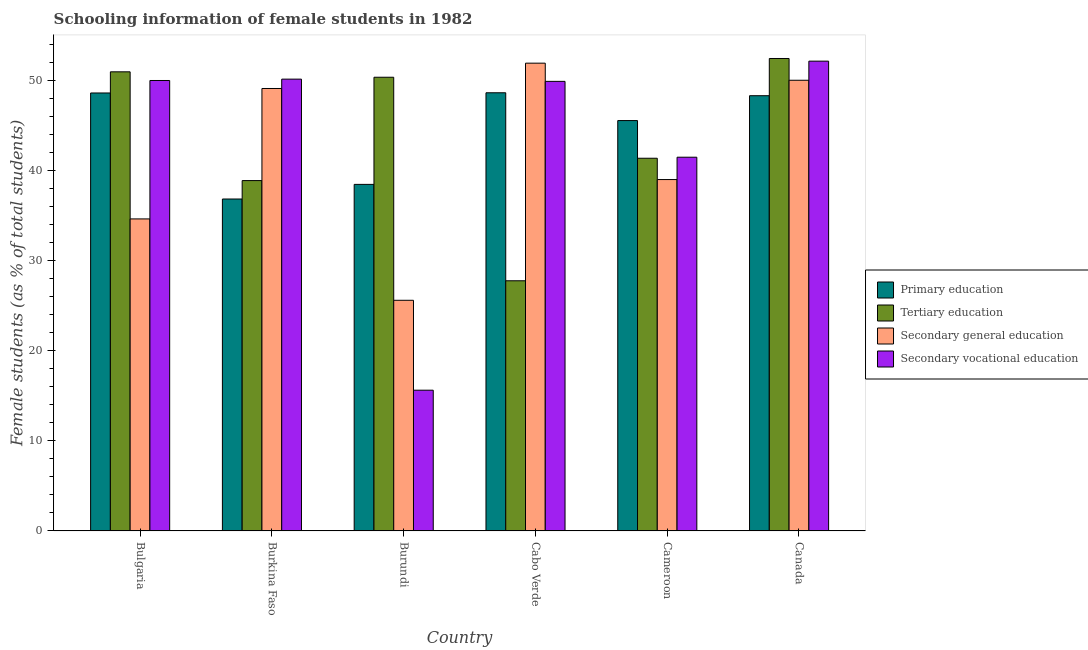How many different coloured bars are there?
Offer a terse response. 4. How many groups of bars are there?
Your answer should be very brief. 6. Are the number of bars per tick equal to the number of legend labels?
Provide a succinct answer. Yes. Are the number of bars on each tick of the X-axis equal?
Make the answer very short. Yes. What is the label of the 2nd group of bars from the left?
Your answer should be very brief. Burkina Faso. What is the percentage of female students in tertiary education in Cameroon?
Provide a short and direct response. 41.37. Across all countries, what is the maximum percentage of female students in secondary vocational education?
Your answer should be very brief. 52.15. Across all countries, what is the minimum percentage of female students in primary education?
Your answer should be very brief. 36.84. In which country was the percentage of female students in primary education maximum?
Keep it short and to the point. Cabo Verde. In which country was the percentage of female students in tertiary education minimum?
Offer a terse response. Cabo Verde. What is the total percentage of female students in secondary vocational education in the graph?
Your response must be concise. 259.31. What is the difference between the percentage of female students in secondary education in Bulgaria and that in Burkina Faso?
Ensure brevity in your answer.  -14.48. What is the difference between the percentage of female students in tertiary education in Burkina Faso and the percentage of female students in secondary education in Burundi?
Provide a succinct answer. 13.29. What is the average percentage of female students in primary education per country?
Provide a short and direct response. 44.4. What is the difference between the percentage of female students in tertiary education and percentage of female students in secondary vocational education in Bulgaria?
Keep it short and to the point. 0.96. What is the ratio of the percentage of female students in primary education in Burkina Faso to that in Canada?
Your answer should be very brief. 0.76. Is the percentage of female students in primary education in Bulgaria less than that in Canada?
Your answer should be very brief. No. What is the difference between the highest and the second highest percentage of female students in secondary vocational education?
Make the answer very short. 2. What is the difference between the highest and the lowest percentage of female students in tertiary education?
Your response must be concise. 24.67. In how many countries, is the percentage of female students in tertiary education greater than the average percentage of female students in tertiary education taken over all countries?
Provide a succinct answer. 3. Is the sum of the percentage of female students in primary education in Burkina Faso and Canada greater than the maximum percentage of female students in secondary vocational education across all countries?
Ensure brevity in your answer.  Yes. What does the 4th bar from the left in Burundi represents?
Make the answer very short. Secondary vocational education. What does the 3rd bar from the right in Canada represents?
Your answer should be compact. Tertiary education. Are all the bars in the graph horizontal?
Your answer should be very brief. No. How many countries are there in the graph?
Your response must be concise. 6. Does the graph contain any zero values?
Your answer should be compact. No. Does the graph contain grids?
Give a very brief answer. No. Where does the legend appear in the graph?
Make the answer very short. Center right. How many legend labels are there?
Provide a short and direct response. 4. What is the title of the graph?
Your response must be concise. Schooling information of female students in 1982. Does "Arable land" appear as one of the legend labels in the graph?
Give a very brief answer. No. What is the label or title of the Y-axis?
Provide a succinct answer. Female students (as % of total students). What is the Female students (as % of total students) of Primary education in Bulgaria?
Keep it short and to the point. 48.61. What is the Female students (as % of total students) in Tertiary education in Bulgaria?
Offer a terse response. 50.96. What is the Female students (as % of total students) in Secondary general education in Bulgaria?
Give a very brief answer. 34.63. What is the Female students (as % of total students) in Secondary vocational education in Bulgaria?
Make the answer very short. 50. What is the Female students (as % of total students) in Primary education in Burkina Faso?
Provide a short and direct response. 36.84. What is the Female students (as % of total students) in Tertiary education in Burkina Faso?
Give a very brief answer. 38.89. What is the Female students (as % of total students) in Secondary general education in Burkina Faso?
Keep it short and to the point. 49.11. What is the Female students (as % of total students) of Secondary vocational education in Burkina Faso?
Your answer should be very brief. 50.15. What is the Female students (as % of total students) in Primary education in Burundi?
Make the answer very short. 38.47. What is the Female students (as % of total students) in Tertiary education in Burundi?
Keep it short and to the point. 50.36. What is the Female students (as % of total students) of Secondary general education in Burundi?
Offer a very short reply. 25.6. What is the Female students (as % of total students) of Secondary vocational education in Burundi?
Your response must be concise. 15.62. What is the Female students (as % of total students) of Primary education in Cabo Verde?
Make the answer very short. 48.64. What is the Female students (as % of total students) in Tertiary education in Cabo Verde?
Keep it short and to the point. 27.77. What is the Female students (as % of total students) in Secondary general education in Cabo Verde?
Offer a terse response. 51.92. What is the Female students (as % of total students) in Secondary vocational education in Cabo Verde?
Offer a terse response. 49.9. What is the Female students (as % of total students) in Primary education in Cameroon?
Ensure brevity in your answer.  45.55. What is the Female students (as % of total students) of Tertiary education in Cameroon?
Provide a succinct answer. 41.37. What is the Female students (as % of total students) in Secondary general education in Cameroon?
Provide a short and direct response. 39. What is the Female students (as % of total students) in Secondary vocational education in Cameroon?
Offer a very short reply. 41.48. What is the Female students (as % of total students) in Primary education in Canada?
Provide a succinct answer. 48.31. What is the Female students (as % of total students) of Tertiary education in Canada?
Provide a short and direct response. 52.44. What is the Female students (as % of total students) in Secondary general education in Canada?
Provide a short and direct response. 50.03. What is the Female students (as % of total students) of Secondary vocational education in Canada?
Your response must be concise. 52.15. Across all countries, what is the maximum Female students (as % of total students) in Primary education?
Ensure brevity in your answer.  48.64. Across all countries, what is the maximum Female students (as % of total students) of Tertiary education?
Provide a short and direct response. 52.44. Across all countries, what is the maximum Female students (as % of total students) of Secondary general education?
Offer a terse response. 51.92. Across all countries, what is the maximum Female students (as % of total students) in Secondary vocational education?
Make the answer very short. 52.15. Across all countries, what is the minimum Female students (as % of total students) in Primary education?
Ensure brevity in your answer.  36.84. Across all countries, what is the minimum Female students (as % of total students) in Tertiary education?
Provide a short and direct response. 27.77. Across all countries, what is the minimum Female students (as % of total students) of Secondary general education?
Keep it short and to the point. 25.6. Across all countries, what is the minimum Female students (as % of total students) of Secondary vocational education?
Give a very brief answer. 15.62. What is the total Female students (as % of total students) of Primary education in the graph?
Offer a very short reply. 266.42. What is the total Female students (as % of total students) in Tertiary education in the graph?
Your response must be concise. 261.79. What is the total Female students (as % of total students) in Secondary general education in the graph?
Offer a very short reply. 250.3. What is the total Female students (as % of total students) in Secondary vocational education in the graph?
Keep it short and to the point. 259.31. What is the difference between the Female students (as % of total students) of Primary education in Bulgaria and that in Burkina Faso?
Ensure brevity in your answer.  11.77. What is the difference between the Female students (as % of total students) of Tertiary education in Bulgaria and that in Burkina Faso?
Offer a very short reply. 12.07. What is the difference between the Female students (as % of total students) in Secondary general education in Bulgaria and that in Burkina Faso?
Give a very brief answer. -14.48. What is the difference between the Female students (as % of total students) in Secondary vocational education in Bulgaria and that in Burkina Faso?
Give a very brief answer. -0.15. What is the difference between the Female students (as % of total students) in Primary education in Bulgaria and that in Burundi?
Keep it short and to the point. 10.15. What is the difference between the Female students (as % of total students) of Tertiary education in Bulgaria and that in Burundi?
Ensure brevity in your answer.  0.6. What is the difference between the Female students (as % of total students) in Secondary general education in Bulgaria and that in Burundi?
Offer a terse response. 9.03. What is the difference between the Female students (as % of total students) of Secondary vocational education in Bulgaria and that in Burundi?
Give a very brief answer. 34.38. What is the difference between the Female students (as % of total students) in Primary education in Bulgaria and that in Cabo Verde?
Keep it short and to the point. -0.02. What is the difference between the Female students (as % of total students) in Tertiary education in Bulgaria and that in Cabo Verde?
Provide a short and direct response. 23.19. What is the difference between the Female students (as % of total students) in Secondary general education in Bulgaria and that in Cabo Verde?
Your answer should be very brief. -17.29. What is the difference between the Female students (as % of total students) of Secondary vocational education in Bulgaria and that in Cabo Verde?
Your answer should be compact. 0.1. What is the difference between the Female students (as % of total students) in Primary education in Bulgaria and that in Cameroon?
Offer a very short reply. 3.06. What is the difference between the Female students (as % of total students) in Tertiary education in Bulgaria and that in Cameroon?
Keep it short and to the point. 9.59. What is the difference between the Female students (as % of total students) of Secondary general education in Bulgaria and that in Cameroon?
Make the answer very short. -4.37. What is the difference between the Female students (as % of total students) of Secondary vocational education in Bulgaria and that in Cameroon?
Provide a short and direct response. 8.52. What is the difference between the Female students (as % of total students) in Primary education in Bulgaria and that in Canada?
Keep it short and to the point. 0.3. What is the difference between the Female students (as % of total students) of Tertiary education in Bulgaria and that in Canada?
Make the answer very short. -1.48. What is the difference between the Female students (as % of total students) of Secondary general education in Bulgaria and that in Canada?
Offer a very short reply. -15.39. What is the difference between the Female students (as % of total students) in Secondary vocational education in Bulgaria and that in Canada?
Offer a terse response. -2.15. What is the difference between the Female students (as % of total students) in Primary education in Burkina Faso and that in Burundi?
Keep it short and to the point. -1.62. What is the difference between the Female students (as % of total students) of Tertiary education in Burkina Faso and that in Burundi?
Your answer should be very brief. -11.47. What is the difference between the Female students (as % of total students) of Secondary general education in Burkina Faso and that in Burundi?
Your answer should be compact. 23.51. What is the difference between the Female students (as % of total students) in Secondary vocational education in Burkina Faso and that in Burundi?
Provide a short and direct response. 34.53. What is the difference between the Female students (as % of total students) of Primary education in Burkina Faso and that in Cabo Verde?
Provide a short and direct response. -11.79. What is the difference between the Female students (as % of total students) of Tertiary education in Burkina Faso and that in Cabo Verde?
Keep it short and to the point. 11.12. What is the difference between the Female students (as % of total students) of Secondary general education in Burkina Faso and that in Cabo Verde?
Provide a short and direct response. -2.81. What is the difference between the Female students (as % of total students) in Secondary vocational education in Burkina Faso and that in Cabo Verde?
Your answer should be compact. 0.25. What is the difference between the Female students (as % of total students) of Primary education in Burkina Faso and that in Cameroon?
Provide a succinct answer. -8.71. What is the difference between the Female students (as % of total students) in Tertiary education in Burkina Faso and that in Cameroon?
Offer a very short reply. -2.48. What is the difference between the Female students (as % of total students) of Secondary general education in Burkina Faso and that in Cameroon?
Give a very brief answer. 10.11. What is the difference between the Female students (as % of total students) of Secondary vocational education in Burkina Faso and that in Cameroon?
Make the answer very short. 8.67. What is the difference between the Female students (as % of total students) in Primary education in Burkina Faso and that in Canada?
Offer a very short reply. -11.47. What is the difference between the Female students (as % of total students) of Tertiary education in Burkina Faso and that in Canada?
Make the answer very short. -13.55. What is the difference between the Female students (as % of total students) in Secondary general education in Burkina Faso and that in Canada?
Your response must be concise. -0.91. What is the difference between the Female students (as % of total students) in Secondary vocational education in Burkina Faso and that in Canada?
Your response must be concise. -2. What is the difference between the Female students (as % of total students) in Primary education in Burundi and that in Cabo Verde?
Offer a very short reply. -10.17. What is the difference between the Female students (as % of total students) in Tertiary education in Burundi and that in Cabo Verde?
Offer a very short reply. 22.59. What is the difference between the Female students (as % of total students) of Secondary general education in Burundi and that in Cabo Verde?
Your answer should be compact. -26.32. What is the difference between the Female students (as % of total students) of Secondary vocational education in Burundi and that in Cabo Verde?
Provide a short and direct response. -34.28. What is the difference between the Female students (as % of total students) of Primary education in Burundi and that in Cameroon?
Provide a succinct answer. -7.08. What is the difference between the Female students (as % of total students) in Tertiary education in Burundi and that in Cameroon?
Offer a terse response. 8.99. What is the difference between the Female students (as % of total students) in Secondary general education in Burundi and that in Cameroon?
Ensure brevity in your answer.  -13.4. What is the difference between the Female students (as % of total students) in Secondary vocational education in Burundi and that in Cameroon?
Offer a terse response. -25.86. What is the difference between the Female students (as % of total students) of Primary education in Burundi and that in Canada?
Offer a terse response. -9.84. What is the difference between the Female students (as % of total students) in Tertiary education in Burundi and that in Canada?
Your answer should be very brief. -2.08. What is the difference between the Female students (as % of total students) of Secondary general education in Burundi and that in Canada?
Your answer should be compact. -24.42. What is the difference between the Female students (as % of total students) of Secondary vocational education in Burundi and that in Canada?
Make the answer very short. -36.52. What is the difference between the Female students (as % of total students) in Primary education in Cabo Verde and that in Cameroon?
Offer a very short reply. 3.09. What is the difference between the Female students (as % of total students) of Tertiary education in Cabo Verde and that in Cameroon?
Provide a short and direct response. -13.6. What is the difference between the Female students (as % of total students) in Secondary general education in Cabo Verde and that in Cameroon?
Keep it short and to the point. 12.92. What is the difference between the Female students (as % of total students) in Secondary vocational education in Cabo Verde and that in Cameroon?
Provide a succinct answer. 8.42. What is the difference between the Female students (as % of total students) of Primary education in Cabo Verde and that in Canada?
Make the answer very short. 0.33. What is the difference between the Female students (as % of total students) of Tertiary education in Cabo Verde and that in Canada?
Make the answer very short. -24.67. What is the difference between the Female students (as % of total students) in Secondary general education in Cabo Verde and that in Canada?
Offer a terse response. 1.9. What is the difference between the Female students (as % of total students) in Secondary vocational education in Cabo Verde and that in Canada?
Provide a succinct answer. -2.24. What is the difference between the Female students (as % of total students) of Primary education in Cameroon and that in Canada?
Provide a succinct answer. -2.76. What is the difference between the Female students (as % of total students) of Tertiary education in Cameroon and that in Canada?
Your answer should be compact. -11.07. What is the difference between the Female students (as % of total students) of Secondary general education in Cameroon and that in Canada?
Your answer should be compact. -11.02. What is the difference between the Female students (as % of total students) in Secondary vocational education in Cameroon and that in Canada?
Offer a terse response. -10.66. What is the difference between the Female students (as % of total students) in Primary education in Bulgaria and the Female students (as % of total students) in Tertiary education in Burkina Faso?
Ensure brevity in your answer.  9.72. What is the difference between the Female students (as % of total students) in Primary education in Bulgaria and the Female students (as % of total students) in Secondary general education in Burkina Faso?
Make the answer very short. -0.5. What is the difference between the Female students (as % of total students) in Primary education in Bulgaria and the Female students (as % of total students) in Secondary vocational education in Burkina Faso?
Provide a short and direct response. -1.54. What is the difference between the Female students (as % of total students) of Tertiary education in Bulgaria and the Female students (as % of total students) of Secondary general education in Burkina Faso?
Your answer should be compact. 1.85. What is the difference between the Female students (as % of total students) in Tertiary education in Bulgaria and the Female students (as % of total students) in Secondary vocational education in Burkina Faso?
Give a very brief answer. 0.81. What is the difference between the Female students (as % of total students) of Secondary general education in Bulgaria and the Female students (as % of total students) of Secondary vocational education in Burkina Faso?
Keep it short and to the point. -15.52. What is the difference between the Female students (as % of total students) of Primary education in Bulgaria and the Female students (as % of total students) of Tertiary education in Burundi?
Your answer should be very brief. -1.75. What is the difference between the Female students (as % of total students) in Primary education in Bulgaria and the Female students (as % of total students) in Secondary general education in Burundi?
Keep it short and to the point. 23.01. What is the difference between the Female students (as % of total students) of Primary education in Bulgaria and the Female students (as % of total students) of Secondary vocational education in Burundi?
Ensure brevity in your answer.  32.99. What is the difference between the Female students (as % of total students) of Tertiary education in Bulgaria and the Female students (as % of total students) of Secondary general education in Burundi?
Keep it short and to the point. 25.36. What is the difference between the Female students (as % of total students) of Tertiary education in Bulgaria and the Female students (as % of total students) of Secondary vocational education in Burundi?
Your answer should be very brief. 35.34. What is the difference between the Female students (as % of total students) of Secondary general education in Bulgaria and the Female students (as % of total students) of Secondary vocational education in Burundi?
Your response must be concise. 19.01. What is the difference between the Female students (as % of total students) of Primary education in Bulgaria and the Female students (as % of total students) of Tertiary education in Cabo Verde?
Your response must be concise. 20.84. What is the difference between the Female students (as % of total students) in Primary education in Bulgaria and the Female students (as % of total students) in Secondary general education in Cabo Verde?
Provide a succinct answer. -3.31. What is the difference between the Female students (as % of total students) in Primary education in Bulgaria and the Female students (as % of total students) in Secondary vocational education in Cabo Verde?
Ensure brevity in your answer.  -1.29. What is the difference between the Female students (as % of total students) of Tertiary education in Bulgaria and the Female students (as % of total students) of Secondary general education in Cabo Verde?
Make the answer very short. -0.96. What is the difference between the Female students (as % of total students) of Tertiary education in Bulgaria and the Female students (as % of total students) of Secondary vocational education in Cabo Verde?
Keep it short and to the point. 1.06. What is the difference between the Female students (as % of total students) in Secondary general education in Bulgaria and the Female students (as % of total students) in Secondary vocational education in Cabo Verde?
Your answer should be very brief. -15.27. What is the difference between the Female students (as % of total students) in Primary education in Bulgaria and the Female students (as % of total students) in Tertiary education in Cameroon?
Your answer should be compact. 7.24. What is the difference between the Female students (as % of total students) in Primary education in Bulgaria and the Female students (as % of total students) in Secondary general education in Cameroon?
Provide a succinct answer. 9.61. What is the difference between the Female students (as % of total students) in Primary education in Bulgaria and the Female students (as % of total students) in Secondary vocational education in Cameroon?
Give a very brief answer. 7.13. What is the difference between the Female students (as % of total students) in Tertiary education in Bulgaria and the Female students (as % of total students) in Secondary general education in Cameroon?
Offer a very short reply. 11.96. What is the difference between the Female students (as % of total students) in Tertiary education in Bulgaria and the Female students (as % of total students) in Secondary vocational education in Cameroon?
Your response must be concise. 9.48. What is the difference between the Female students (as % of total students) in Secondary general education in Bulgaria and the Female students (as % of total students) in Secondary vocational education in Cameroon?
Provide a succinct answer. -6.85. What is the difference between the Female students (as % of total students) of Primary education in Bulgaria and the Female students (as % of total students) of Tertiary education in Canada?
Provide a succinct answer. -3.83. What is the difference between the Female students (as % of total students) of Primary education in Bulgaria and the Female students (as % of total students) of Secondary general education in Canada?
Offer a very short reply. -1.41. What is the difference between the Female students (as % of total students) of Primary education in Bulgaria and the Female students (as % of total students) of Secondary vocational education in Canada?
Provide a short and direct response. -3.53. What is the difference between the Female students (as % of total students) of Tertiary education in Bulgaria and the Female students (as % of total students) of Secondary general education in Canada?
Provide a succinct answer. 0.94. What is the difference between the Female students (as % of total students) in Tertiary education in Bulgaria and the Female students (as % of total students) in Secondary vocational education in Canada?
Keep it short and to the point. -1.19. What is the difference between the Female students (as % of total students) of Secondary general education in Bulgaria and the Female students (as % of total students) of Secondary vocational education in Canada?
Offer a very short reply. -17.51. What is the difference between the Female students (as % of total students) of Primary education in Burkina Faso and the Female students (as % of total students) of Tertiary education in Burundi?
Ensure brevity in your answer.  -13.52. What is the difference between the Female students (as % of total students) in Primary education in Burkina Faso and the Female students (as % of total students) in Secondary general education in Burundi?
Give a very brief answer. 11.24. What is the difference between the Female students (as % of total students) in Primary education in Burkina Faso and the Female students (as % of total students) in Secondary vocational education in Burundi?
Ensure brevity in your answer.  21.22. What is the difference between the Female students (as % of total students) of Tertiary education in Burkina Faso and the Female students (as % of total students) of Secondary general education in Burundi?
Provide a short and direct response. 13.29. What is the difference between the Female students (as % of total students) of Tertiary education in Burkina Faso and the Female students (as % of total students) of Secondary vocational education in Burundi?
Your answer should be very brief. 23.27. What is the difference between the Female students (as % of total students) in Secondary general education in Burkina Faso and the Female students (as % of total students) in Secondary vocational education in Burundi?
Give a very brief answer. 33.49. What is the difference between the Female students (as % of total students) of Primary education in Burkina Faso and the Female students (as % of total students) of Tertiary education in Cabo Verde?
Ensure brevity in your answer.  9.08. What is the difference between the Female students (as % of total students) in Primary education in Burkina Faso and the Female students (as % of total students) in Secondary general education in Cabo Verde?
Give a very brief answer. -15.08. What is the difference between the Female students (as % of total students) in Primary education in Burkina Faso and the Female students (as % of total students) in Secondary vocational education in Cabo Verde?
Ensure brevity in your answer.  -13.06. What is the difference between the Female students (as % of total students) in Tertiary education in Burkina Faso and the Female students (as % of total students) in Secondary general education in Cabo Verde?
Keep it short and to the point. -13.03. What is the difference between the Female students (as % of total students) in Tertiary education in Burkina Faso and the Female students (as % of total students) in Secondary vocational education in Cabo Verde?
Your answer should be compact. -11.01. What is the difference between the Female students (as % of total students) of Secondary general education in Burkina Faso and the Female students (as % of total students) of Secondary vocational education in Cabo Verde?
Your answer should be compact. -0.79. What is the difference between the Female students (as % of total students) of Primary education in Burkina Faso and the Female students (as % of total students) of Tertiary education in Cameroon?
Keep it short and to the point. -4.53. What is the difference between the Female students (as % of total students) of Primary education in Burkina Faso and the Female students (as % of total students) of Secondary general education in Cameroon?
Provide a short and direct response. -2.16. What is the difference between the Female students (as % of total students) in Primary education in Burkina Faso and the Female students (as % of total students) in Secondary vocational education in Cameroon?
Provide a succinct answer. -4.64. What is the difference between the Female students (as % of total students) of Tertiary education in Burkina Faso and the Female students (as % of total students) of Secondary general education in Cameroon?
Make the answer very short. -0.11. What is the difference between the Female students (as % of total students) in Tertiary education in Burkina Faso and the Female students (as % of total students) in Secondary vocational education in Cameroon?
Your answer should be very brief. -2.6. What is the difference between the Female students (as % of total students) in Secondary general education in Burkina Faso and the Female students (as % of total students) in Secondary vocational education in Cameroon?
Ensure brevity in your answer.  7.63. What is the difference between the Female students (as % of total students) of Primary education in Burkina Faso and the Female students (as % of total students) of Tertiary education in Canada?
Give a very brief answer. -15.6. What is the difference between the Female students (as % of total students) of Primary education in Burkina Faso and the Female students (as % of total students) of Secondary general education in Canada?
Give a very brief answer. -13.18. What is the difference between the Female students (as % of total students) in Primary education in Burkina Faso and the Female students (as % of total students) in Secondary vocational education in Canada?
Give a very brief answer. -15.3. What is the difference between the Female students (as % of total students) in Tertiary education in Burkina Faso and the Female students (as % of total students) in Secondary general education in Canada?
Give a very brief answer. -11.14. What is the difference between the Female students (as % of total students) in Tertiary education in Burkina Faso and the Female students (as % of total students) in Secondary vocational education in Canada?
Your answer should be very brief. -13.26. What is the difference between the Female students (as % of total students) of Secondary general education in Burkina Faso and the Female students (as % of total students) of Secondary vocational education in Canada?
Your response must be concise. -3.04. What is the difference between the Female students (as % of total students) of Primary education in Burundi and the Female students (as % of total students) of Tertiary education in Cabo Verde?
Give a very brief answer. 10.7. What is the difference between the Female students (as % of total students) in Primary education in Burundi and the Female students (as % of total students) in Secondary general education in Cabo Verde?
Your answer should be compact. -13.45. What is the difference between the Female students (as % of total students) of Primary education in Burundi and the Female students (as % of total students) of Secondary vocational education in Cabo Verde?
Offer a terse response. -11.44. What is the difference between the Female students (as % of total students) of Tertiary education in Burundi and the Female students (as % of total students) of Secondary general education in Cabo Verde?
Your answer should be very brief. -1.56. What is the difference between the Female students (as % of total students) of Tertiary education in Burundi and the Female students (as % of total students) of Secondary vocational education in Cabo Verde?
Your response must be concise. 0.46. What is the difference between the Female students (as % of total students) in Secondary general education in Burundi and the Female students (as % of total students) in Secondary vocational education in Cabo Verde?
Give a very brief answer. -24.3. What is the difference between the Female students (as % of total students) in Primary education in Burundi and the Female students (as % of total students) in Tertiary education in Cameroon?
Your answer should be compact. -2.9. What is the difference between the Female students (as % of total students) of Primary education in Burundi and the Female students (as % of total students) of Secondary general education in Cameroon?
Make the answer very short. -0.54. What is the difference between the Female students (as % of total students) of Primary education in Burundi and the Female students (as % of total students) of Secondary vocational education in Cameroon?
Your response must be concise. -3.02. What is the difference between the Female students (as % of total students) of Tertiary education in Burundi and the Female students (as % of total students) of Secondary general education in Cameroon?
Give a very brief answer. 11.36. What is the difference between the Female students (as % of total students) of Tertiary education in Burundi and the Female students (as % of total students) of Secondary vocational education in Cameroon?
Make the answer very short. 8.88. What is the difference between the Female students (as % of total students) of Secondary general education in Burundi and the Female students (as % of total students) of Secondary vocational education in Cameroon?
Provide a succinct answer. -15.88. What is the difference between the Female students (as % of total students) of Primary education in Burundi and the Female students (as % of total students) of Tertiary education in Canada?
Make the answer very short. -13.97. What is the difference between the Female students (as % of total students) of Primary education in Burundi and the Female students (as % of total students) of Secondary general education in Canada?
Your answer should be compact. -11.56. What is the difference between the Female students (as % of total students) of Primary education in Burundi and the Female students (as % of total students) of Secondary vocational education in Canada?
Provide a succinct answer. -13.68. What is the difference between the Female students (as % of total students) of Tertiary education in Burundi and the Female students (as % of total students) of Secondary general education in Canada?
Your response must be concise. 0.33. What is the difference between the Female students (as % of total students) of Tertiary education in Burundi and the Female students (as % of total students) of Secondary vocational education in Canada?
Keep it short and to the point. -1.79. What is the difference between the Female students (as % of total students) in Secondary general education in Burundi and the Female students (as % of total students) in Secondary vocational education in Canada?
Ensure brevity in your answer.  -26.55. What is the difference between the Female students (as % of total students) of Primary education in Cabo Verde and the Female students (as % of total students) of Tertiary education in Cameroon?
Provide a short and direct response. 7.27. What is the difference between the Female students (as % of total students) in Primary education in Cabo Verde and the Female students (as % of total students) in Secondary general education in Cameroon?
Provide a succinct answer. 9.63. What is the difference between the Female students (as % of total students) of Primary education in Cabo Verde and the Female students (as % of total students) of Secondary vocational education in Cameroon?
Your answer should be compact. 7.15. What is the difference between the Female students (as % of total students) of Tertiary education in Cabo Verde and the Female students (as % of total students) of Secondary general education in Cameroon?
Provide a short and direct response. -11.23. What is the difference between the Female students (as % of total students) in Tertiary education in Cabo Verde and the Female students (as % of total students) in Secondary vocational education in Cameroon?
Keep it short and to the point. -13.72. What is the difference between the Female students (as % of total students) in Secondary general education in Cabo Verde and the Female students (as % of total students) in Secondary vocational education in Cameroon?
Make the answer very short. 10.44. What is the difference between the Female students (as % of total students) of Primary education in Cabo Verde and the Female students (as % of total students) of Tertiary education in Canada?
Ensure brevity in your answer.  -3.8. What is the difference between the Female students (as % of total students) of Primary education in Cabo Verde and the Female students (as % of total students) of Secondary general education in Canada?
Provide a succinct answer. -1.39. What is the difference between the Female students (as % of total students) in Primary education in Cabo Verde and the Female students (as % of total students) in Secondary vocational education in Canada?
Provide a succinct answer. -3.51. What is the difference between the Female students (as % of total students) of Tertiary education in Cabo Verde and the Female students (as % of total students) of Secondary general education in Canada?
Your answer should be compact. -22.26. What is the difference between the Female students (as % of total students) of Tertiary education in Cabo Verde and the Female students (as % of total students) of Secondary vocational education in Canada?
Your answer should be very brief. -24.38. What is the difference between the Female students (as % of total students) of Secondary general education in Cabo Verde and the Female students (as % of total students) of Secondary vocational education in Canada?
Offer a very short reply. -0.22. What is the difference between the Female students (as % of total students) of Primary education in Cameroon and the Female students (as % of total students) of Tertiary education in Canada?
Your answer should be very brief. -6.89. What is the difference between the Female students (as % of total students) in Primary education in Cameroon and the Female students (as % of total students) in Secondary general education in Canada?
Provide a succinct answer. -4.47. What is the difference between the Female students (as % of total students) in Primary education in Cameroon and the Female students (as % of total students) in Secondary vocational education in Canada?
Your answer should be very brief. -6.6. What is the difference between the Female students (as % of total students) in Tertiary education in Cameroon and the Female students (as % of total students) in Secondary general education in Canada?
Offer a terse response. -8.66. What is the difference between the Female students (as % of total students) of Tertiary education in Cameroon and the Female students (as % of total students) of Secondary vocational education in Canada?
Offer a very short reply. -10.78. What is the difference between the Female students (as % of total students) in Secondary general education in Cameroon and the Female students (as % of total students) in Secondary vocational education in Canada?
Ensure brevity in your answer.  -13.14. What is the average Female students (as % of total students) of Primary education per country?
Keep it short and to the point. 44.4. What is the average Female students (as % of total students) of Tertiary education per country?
Offer a terse response. 43.63. What is the average Female students (as % of total students) in Secondary general education per country?
Give a very brief answer. 41.72. What is the average Female students (as % of total students) in Secondary vocational education per country?
Give a very brief answer. 43.22. What is the difference between the Female students (as % of total students) in Primary education and Female students (as % of total students) in Tertiary education in Bulgaria?
Your answer should be very brief. -2.35. What is the difference between the Female students (as % of total students) in Primary education and Female students (as % of total students) in Secondary general education in Bulgaria?
Your answer should be compact. 13.98. What is the difference between the Female students (as % of total students) in Primary education and Female students (as % of total students) in Secondary vocational education in Bulgaria?
Give a very brief answer. -1.39. What is the difference between the Female students (as % of total students) of Tertiary education and Female students (as % of total students) of Secondary general education in Bulgaria?
Your response must be concise. 16.33. What is the difference between the Female students (as % of total students) of Tertiary education and Female students (as % of total students) of Secondary vocational education in Bulgaria?
Your answer should be very brief. 0.96. What is the difference between the Female students (as % of total students) in Secondary general education and Female students (as % of total students) in Secondary vocational education in Bulgaria?
Offer a very short reply. -15.37. What is the difference between the Female students (as % of total students) of Primary education and Female students (as % of total students) of Tertiary education in Burkina Faso?
Your response must be concise. -2.04. What is the difference between the Female students (as % of total students) in Primary education and Female students (as % of total students) in Secondary general education in Burkina Faso?
Keep it short and to the point. -12.27. What is the difference between the Female students (as % of total students) in Primary education and Female students (as % of total students) in Secondary vocational education in Burkina Faso?
Give a very brief answer. -13.31. What is the difference between the Female students (as % of total students) of Tertiary education and Female students (as % of total students) of Secondary general education in Burkina Faso?
Your answer should be very brief. -10.22. What is the difference between the Female students (as % of total students) of Tertiary education and Female students (as % of total students) of Secondary vocational education in Burkina Faso?
Provide a short and direct response. -11.26. What is the difference between the Female students (as % of total students) of Secondary general education and Female students (as % of total students) of Secondary vocational education in Burkina Faso?
Give a very brief answer. -1.04. What is the difference between the Female students (as % of total students) of Primary education and Female students (as % of total students) of Tertiary education in Burundi?
Give a very brief answer. -11.89. What is the difference between the Female students (as % of total students) of Primary education and Female students (as % of total students) of Secondary general education in Burundi?
Provide a succinct answer. 12.87. What is the difference between the Female students (as % of total students) in Primary education and Female students (as % of total students) in Secondary vocational education in Burundi?
Provide a short and direct response. 22.84. What is the difference between the Female students (as % of total students) of Tertiary education and Female students (as % of total students) of Secondary general education in Burundi?
Make the answer very short. 24.76. What is the difference between the Female students (as % of total students) of Tertiary education and Female students (as % of total students) of Secondary vocational education in Burundi?
Offer a very short reply. 34.74. What is the difference between the Female students (as % of total students) in Secondary general education and Female students (as % of total students) in Secondary vocational education in Burundi?
Your response must be concise. 9.98. What is the difference between the Female students (as % of total students) in Primary education and Female students (as % of total students) in Tertiary education in Cabo Verde?
Provide a short and direct response. 20.87. What is the difference between the Female students (as % of total students) of Primary education and Female students (as % of total students) of Secondary general education in Cabo Verde?
Your answer should be very brief. -3.29. What is the difference between the Female students (as % of total students) in Primary education and Female students (as % of total students) in Secondary vocational education in Cabo Verde?
Offer a terse response. -1.27. What is the difference between the Female students (as % of total students) in Tertiary education and Female students (as % of total students) in Secondary general education in Cabo Verde?
Ensure brevity in your answer.  -24.15. What is the difference between the Female students (as % of total students) in Tertiary education and Female students (as % of total students) in Secondary vocational education in Cabo Verde?
Offer a terse response. -22.13. What is the difference between the Female students (as % of total students) in Secondary general education and Female students (as % of total students) in Secondary vocational education in Cabo Verde?
Give a very brief answer. 2.02. What is the difference between the Female students (as % of total students) in Primary education and Female students (as % of total students) in Tertiary education in Cameroon?
Your answer should be compact. 4.18. What is the difference between the Female students (as % of total students) of Primary education and Female students (as % of total students) of Secondary general education in Cameroon?
Give a very brief answer. 6.55. What is the difference between the Female students (as % of total students) of Primary education and Female students (as % of total students) of Secondary vocational education in Cameroon?
Give a very brief answer. 4.07. What is the difference between the Female students (as % of total students) in Tertiary education and Female students (as % of total students) in Secondary general education in Cameroon?
Your answer should be very brief. 2.37. What is the difference between the Female students (as % of total students) in Tertiary education and Female students (as % of total students) in Secondary vocational education in Cameroon?
Provide a succinct answer. -0.11. What is the difference between the Female students (as % of total students) in Secondary general education and Female students (as % of total students) in Secondary vocational education in Cameroon?
Make the answer very short. -2.48. What is the difference between the Female students (as % of total students) in Primary education and Female students (as % of total students) in Tertiary education in Canada?
Give a very brief answer. -4.13. What is the difference between the Female students (as % of total students) of Primary education and Female students (as % of total students) of Secondary general education in Canada?
Provide a succinct answer. -1.72. What is the difference between the Female students (as % of total students) in Primary education and Female students (as % of total students) in Secondary vocational education in Canada?
Your answer should be compact. -3.84. What is the difference between the Female students (as % of total students) of Tertiary education and Female students (as % of total students) of Secondary general education in Canada?
Offer a very short reply. 2.42. What is the difference between the Female students (as % of total students) of Tertiary education and Female students (as % of total students) of Secondary vocational education in Canada?
Provide a short and direct response. 0.29. What is the difference between the Female students (as % of total students) of Secondary general education and Female students (as % of total students) of Secondary vocational education in Canada?
Your response must be concise. -2.12. What is the ratio of the Female students (as % of total students) in Primary education in Bulgaria to that in Burkina Faso?
Your answer should be very brief. 1.32. What is the ratio of the Female students (as % of total students) of Tertiary education in Bulgaria to that in Burkina Faso?
Offer a very short reply. 1.31. What is the ratio of the Female students (as % of total students) of Secondary general education in Bulgaria to that in Burkina Faso?
Your response must be concise. 0.71. What is the ratio of the Female students (as % of total students) of Secondary vocational education in Bulgaria to that in Burkina Faso?
Keep it short and to the point. 1. What is the ratio of the Female students (as % of total students) in Primary education in Bulgaria to that in Burundi?
Give a very brief answer. 1.26. What is the ratio of the Female students (as % of total students) of Tertiary education in Bulgaria to that in Burundi?
Keep it short and to the point. 1.01. What is the ratio of the Female students (as % of total students) of Secondary general education in Bulgaria to that in Burundi?
Your response must be concise. 1.35. What is the ratio of the Female students (as % of total students) in Secondary vocational education in Bulgaria to that in Burundi?
Ensure brevity in your answer.  3.2. What is the ratio of the Female students (as % of total students) in Tertiary education in Bulgaria to that in Cabo Verde?
Offer a terse response. 1.84. What is the ratio of the Female students (as % of total students) in Secondary general education in Bulgaria to that in Cabo Verde?
Your answer should be compact. 0.67. What is the ratio of the Female students (as % of total students) in Secondary vocational education in Bulgaria to that in Cabo Verde?
Provide a short and direct response. 1. What is the ratio of the Female students (as % of total students) in Primary education in Bulgaria to that in Cameroon?
Your response must be concise. 1.07. What is the ratio of the Female students (as % of total students) in Tertiary education in Bulgaria to that in Cameroon?
Make the answer very short. 1.23. What is the ratio of the Female students (as % of total students) of Secondary general education in Bulgaria to that in Cameroon?
Provide a succinct answer. 0.89. What is the ratio of the Female students (as % of total students) of Secondary vocational education in Bulgaria to that in Cameroon?
Provide a short and direct response. 1.21. What is the ratio of the Female students (as % of total students) in Tertiary education in Bulgaria to that in Canada?
Provide a short and direct response. 0.97. What is the ratio of the Female students (as % of total students) of Secondary general education in Bulgaria to that in Canada?
Your answer should be compact. 0.69. What is the ratio of the Female students (as % of total students) of Secondary vocational education in Bulgaria to that in Canada?
Provide a short and direct response. 0.96. What is the ratio of the Female students (as % of total students) of Primary education in Burkina Faso to that in Burundi?
Your answer should be very brief. 0.96. What is the ratio of the Female students (as % of total students) of Tertiary education in Burkina Faso to that in Burundi?
Provide a short and direct response. 0.77. What is the ratio of the Female students (as % of total students) in Secondary general education in Burkina Faso to that in Burundi?
Your answer should be very brief. 1.92. What is the ratio of the Female students (as % of total students) of Secondary vocational education in Burkina Faso to that in Burundi?
Ensure brevity in your answer.  3.21. What is the ratio of the Female students (as % of total students) in Primary education in Burkina Faso to that in Cabo Verde?
Offer a terse response. 0.76. What is the ratio of the Female students (as % of total students) of Tertiary education in Burkina Faso to that in Cabo Verde?
Provide a short and direct response. 1.4. What is the ratio of the Female students (as % of total students) in Secondary general education in Burkina Faso to that in Cabo Verde?
Offer a very short reply. 0.95. What is the ratio of the Female students (as % of total students) of Secondary vocational education in Burkina Faso to that in Cabo Verde?
Give a very brief answer. 1. What is the ratio of the Female students (as % of total students) in Primary education in Burkina Faso to that in Cameroon?
Offer a terse response. 0.81. What is the ratio of the Female students (as % of total students) in Secondary general education in Burkina Faso to that in Cameroon?
Your response must be concise. 1.26. What is the ratio of the Female students (as % of total students) in Secondary vocational education in Burkina Faso to that in Cameroon?
Your response must be concise. 1.21. What is the ratio of the Female students (as % of total students) of Primary education in Burkina Faso to that in Canada?
Ensure brevity in your answer.  0.76. What is the ratio of the Female students (as % of total students) in Tertiary education in Burkina Faso to that in Canada?
Your answer should be very brief. 0.74. What is the ratio of the Female students (as % of total students) of Secondary general education in Burkina Faso to that in Canada?
Provide a succinct answer. 0.98. What is the ratio of the Female students (as % of total students) in Secondary vocational education in Burkina Faso to that in Canada?
Keep it short and to the point. 0.96. What is the ratio of the Female students (as % of total students) of Primary education in Burundi to that in Cabo Verde?
Your answer should be very brief. 0.79. What is the ratio of the Female students (as % of total students) of Tertiary education in Burundi to that in Cabo Verde?
Ensure brevity in your answer.  1.81. What is the ratio of the Female students (as % of total students) in Secondary general education in Burundi to that in Cabo Verde?
Make the answer very short. 0.49. What is the ratio of the Female students (as % of total students) in Secondary vocational education in Burundi to that in Cabo Verde?
Offer a very short reply. 0.31. What is the ratio of the Female students (as % of total students) in Primary education in Burundi to that in Cameroon?
Give a very brief answer. 0.84. What is the ratio of the Female students (as % of total students) of Tertiary education in Burundi to that in Cameroon?
Ensure brevity in your answer.  1.22. What is the ratio of the Female students (as % of total students) in Secondary general education in Burundi to that in Cameroon?
Keep it short and to the point. 0.66. What is the ratio of the Female students (as % of total students) in Secondary vocational education in Burundi to that in Cameroon?
Provide a succinct answer. 0.38. What is the ratio of the Female students (as % of total students) of Primary education in Burundi to that in Canada?
Give a very brief answer. 0.8. What is the ratio of the Female students (as % of total students) in Tertiary education in Burundi to that in Canada?
Your response must be concise. 0.96. What is the ratio of the Female students (as % of total students) in Secondary general education in Burundi to that in Canada?
Your answer should be compact. 0.51. What is the ratio of the Female students (as % of total students) in Secondary vocational education in Burundi to that in Canada?
Your answer should be compact. 0.3. What is the ratio of the Female students (as % of total students) in Primary education in Cabo Verde to that in Cameroon?
Provide a succinct answer. 1.07. What is the ratio of the Female students (as % of total students) in Tertiary education in Cabo Verde to that in Cameroon?
Ensure brevity in your answer.  0.67. What is the ratio of the Female students (as % of total students) of Secondary general education in Cabo Verde to that in Cameroon?
Provide a short and direct response. 1.33. What is the ratio of the Female students (as % of total students) in Secondary vocational education in Cabo Verde to that in Cameroon?
Provide a short and direct response. 1.2. What is the ratio of the Female students (as % of total students) of Primary education in Cabo Verde to that in Canada?
Provide a short and direct response. 1.01. What is the ratio of the Female students (as % of total students) of Tertiary education in Cabo Verde to that in Canada?
Keep it short and to the point. 0.53. What is the ratio of the Female students (as % of total students) in Secondary general education in Cabo Verde to that in Canada?
Your answer should be very brief. 1.04. What is the ratio of the Female students (as % of total students) in Secondary vocational education in Cabo Verde to that in Canada?
Your answer should be very brief. 0.96. What is the ratio of the Female students (as % of total students) in Primary education in Cameroon to that in Canada?
Offer a very short reply. 0.94. What is the ratio of the Female students (as % of total students) in Tertiary education in Cameroon to that in Canada?
Offer a very short reply. 0.79. What is the ratio of the Female students (as % of total students) of Secondary general education in Cameroon to that in Canada?
Provide a short and direct response. 0.78. What is the ratio of the Female students (as % of total students) of Secondary vocational education in Cameroon to that in Canada?
Your answer should be compact. 0.8. What is the difference between the highest and the second highest Female students (as % of total students) of Primary education?
Offer a very short reply. 0.02. What is the difference between the highest and the second highest Female students (as % of total students) in Tertiary education?
Give a very brief answer. 1.48. What is the difference between the highest and the second highest Female students (as % of total students) in Secondary general education?
Your answer should be very brief. 1.9. What is the difference between the highest and the second highest Female students (as % of total students) of Secondary vocational education?
Ensure brevity in your answer.  2. What is the difference between the highest and the lowest Female students (as % of total students) of Primary education?
Your answer should be very brief. 11.79. What is the difference between the highest and the lowest Female students (as % of total students) in Tertiary education?
Make the answer very short. 24.67. What is the difference between the highest and the lowest Female students (as % of total students) in Secondary general education?
Your answer should be compact. 26.32. What is the difference between the highest and the lowest Female students (as % of total students) in Secondary vocational education?
Keep it short and to the point. 36.52. 